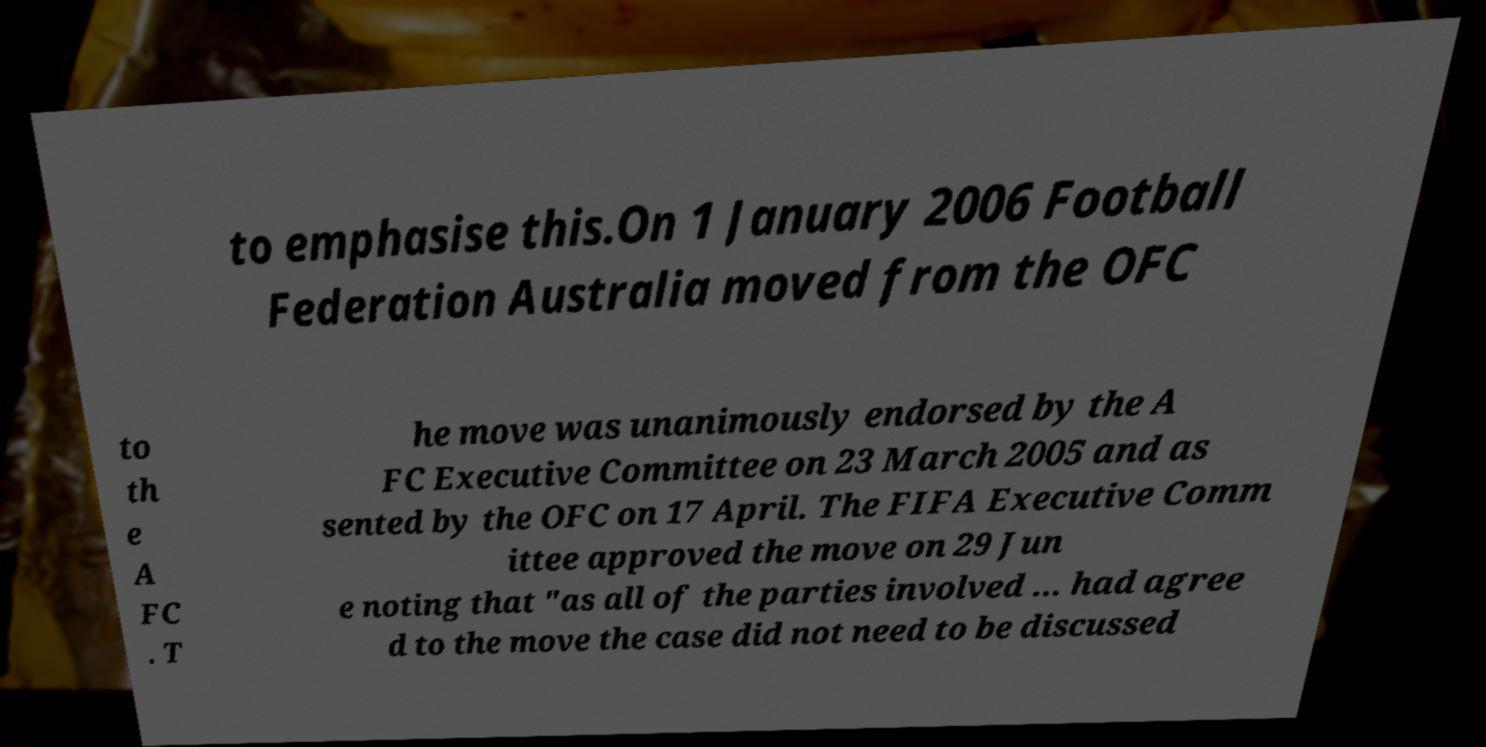What messages or text are displayed in this image? I need them in a readable, typed format. to emphasise this.On 1 January 2006 Football Federation Australia moved from the OFC to th e A FC . T he move was unanimously endorsed by the A FC Executive Committee on 23 March 2005 and as sented by the OFC on 17 April. The FIFA Executive Comm ittee approved the move on 29 Jun e noting that "as all of the parties involved ... had agree d to the move the case did not need to be discussed 